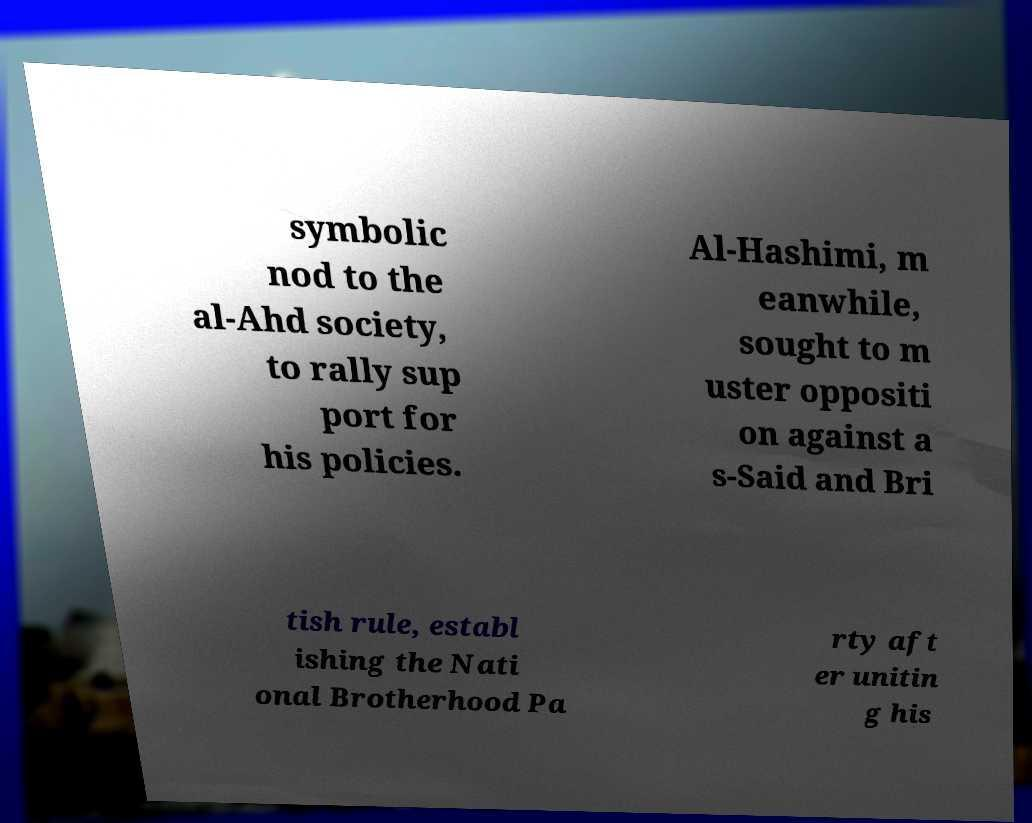Can you read and provide the text displayed in the image?This photo seems to have some interesting text. Can you extract and type it out for me? symbolic nod to the al-Ahd society, to rally sup port for his policies. Al-Hashimi, m eanwhile, sought to m uster oppositi on against a s-Said and Bri tish rule, establ ishing the Nati onal Brotherhood Pa rty aft er unitin g his 